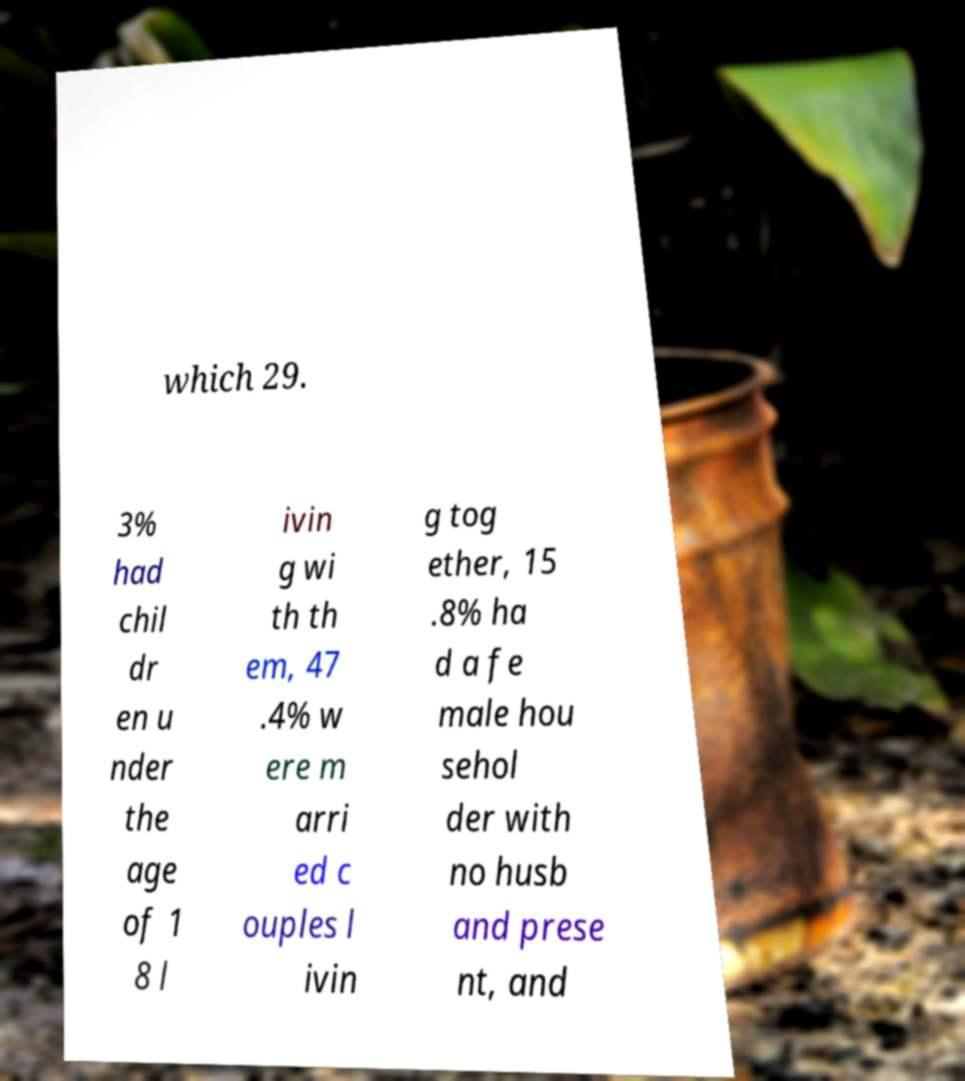Can you read and provide the text displayed in the image?This photo seems to have some interesting text. Can you extract and type it out for me? which 29. 3% had chil dr en u nder the age of 1 8 l ivin g wi th th em, 47 .4% w ere m arri ed c ouples l ivin g tog ether, 15 .8% ha d a fe male hou sehol der with no husb and prese nt, and 